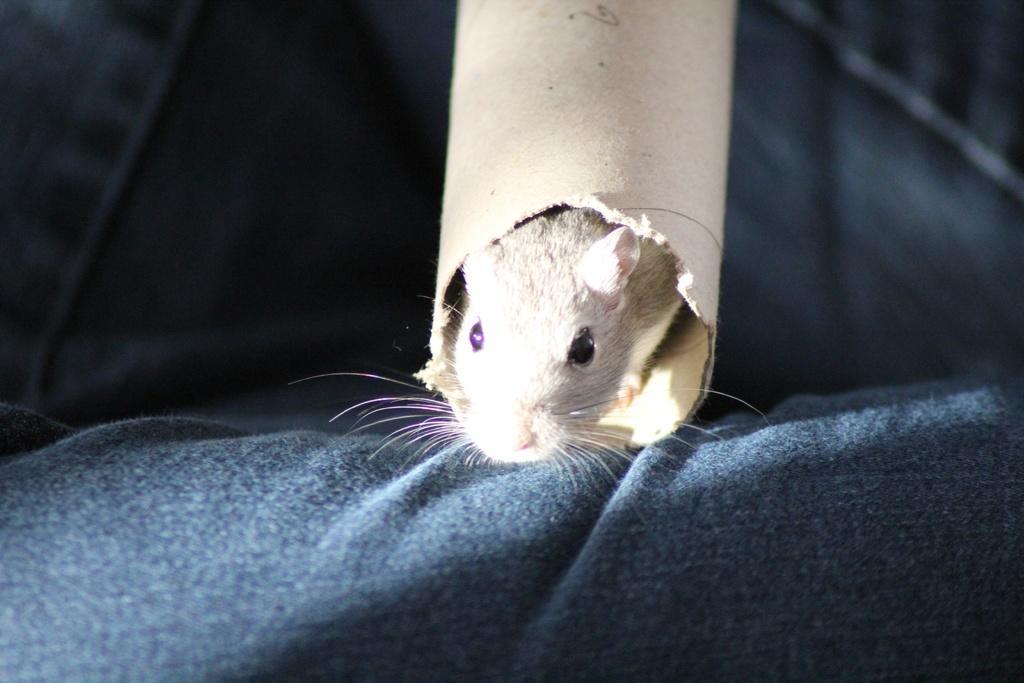Can you describe this image briefly? At the bottom of this image there is a cloth. At the top there is a rat inside a pole. The background is blurred. 